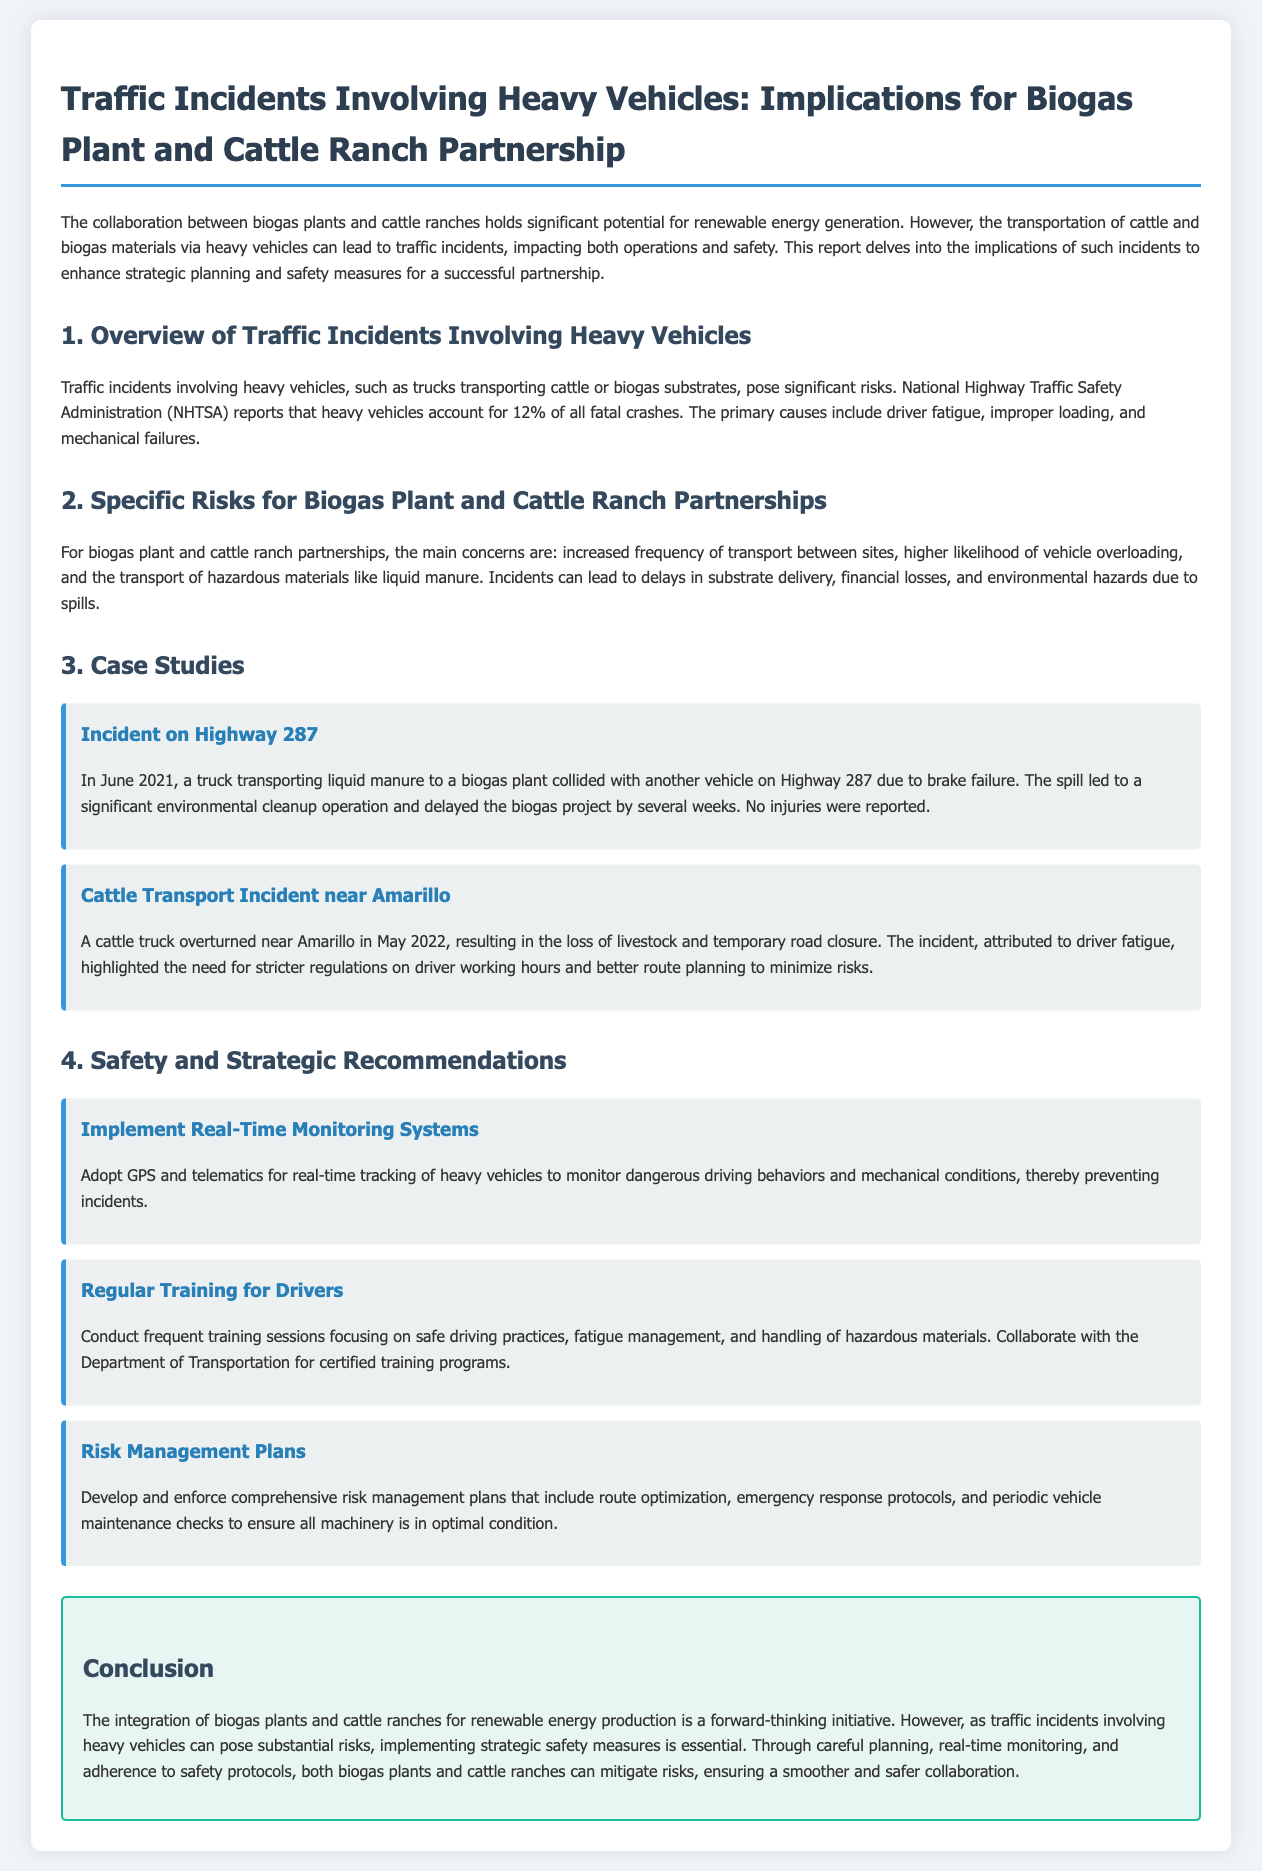What percentage of fatal crashes are attributed to heavy vehicles? The document states that heavy vehicles account for 12% of all fatal crashes.
Answer: 12% What is a primary cause of traffic incidents involving heavy vehicles? The report mentions driver fatigue, improper loading, and mechanical failures as primary causes.
Answer: Driver fatigue What incident occurred on Highway 287? The document details a truck transporting liquid manure colliding with another vehicle due to brake failure.
Answer: Collision due to brake failure What happened in the cattle transport incident near Amarillo? It states that a cattle truck overturned, resulting in loss of livestock and temporary road closure.
Answer: Cattle truck overturned What is one recommendation for improving driver safety? The report suggests conducting frequent training sessions focusing on safe driving practices and fatigue management.
Answer: Regular training for drivers How can real-time monitoring help prevent incidents? By adopting GPS and telematics for tracking heavy vehicles to monitor dangerous behaviors and mechanical conditions.
Answer: Monitor dangerous driving behaviors What year did the cattle transport incident occur? The document specifies that the cattle transport incident near Amarillo happened in May 2022.
Answer: May 2022 What type of materials are of concern during transportation for biogas plants and cattle ranches? The report highlights hazardous materials like liquid manure as a concern during transportation.
Answer: Liquid manure 